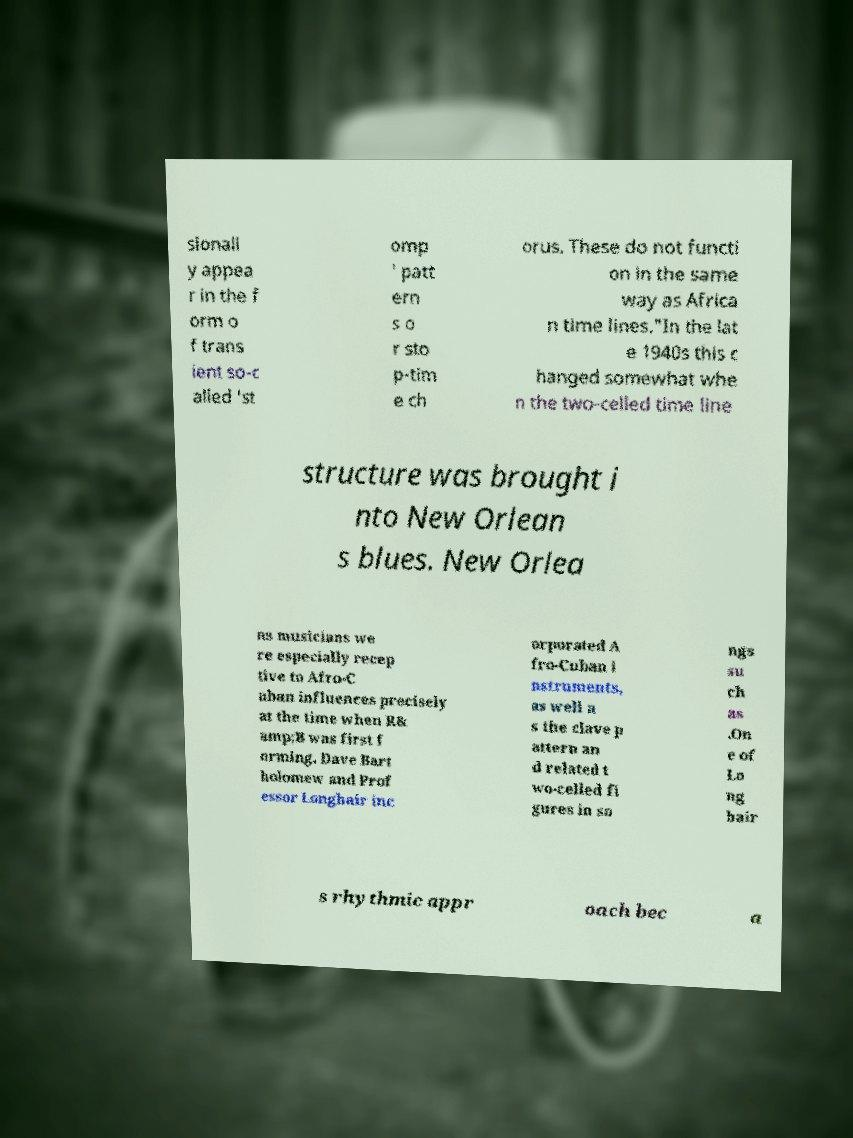Please identify and transcribe the text found in this image. sionall y appea r in the f orm o f trans ient so-c alled 'st omp ' patt ern s o r sto p-tim e ch orus. These do not functi on in the same way as Africa n time lines."In the lat e 1940s this c hanged somewhat whe n the two-celled time line structure was brought i nto New Orlean s blues. New Orlea ns musicians we re especially recep tive to Afro-C uban influences precisely at the time when R& amp;B was first f orming. Dave Bart holomew and Prof essor Longhair inc orporated A fro-Cuban i nstruments, as well a s the clave p attern an d related t wo-celled fi gures in so ngs su ch as .On e of Lo ng hair s rhythmic appr oach bec a 